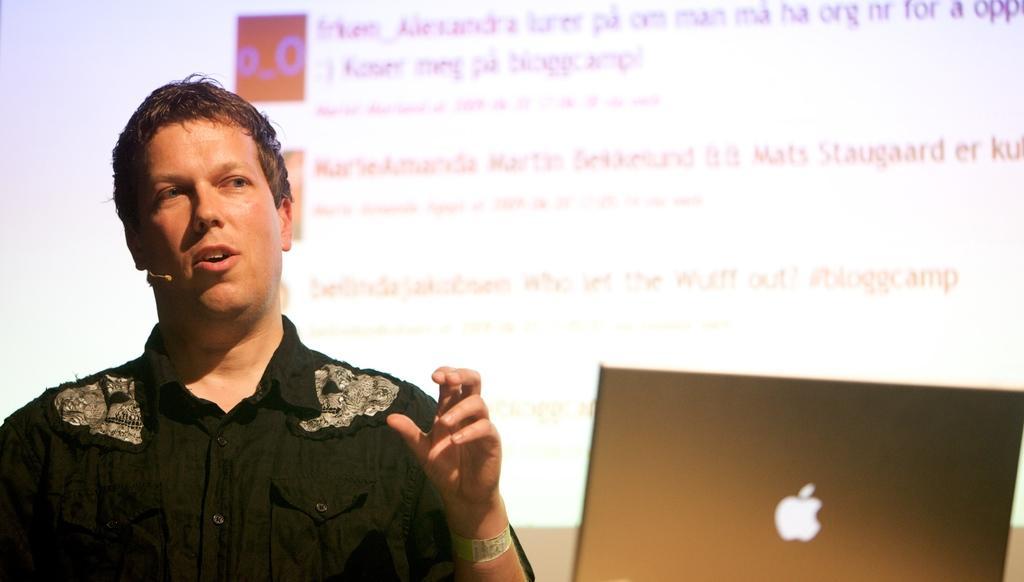Describe this image in one or two sentences. In this image there is a man in the middle who is having a mic to his ear. In front of him there is a laptop. In the background there is a screen on which there is some text. 